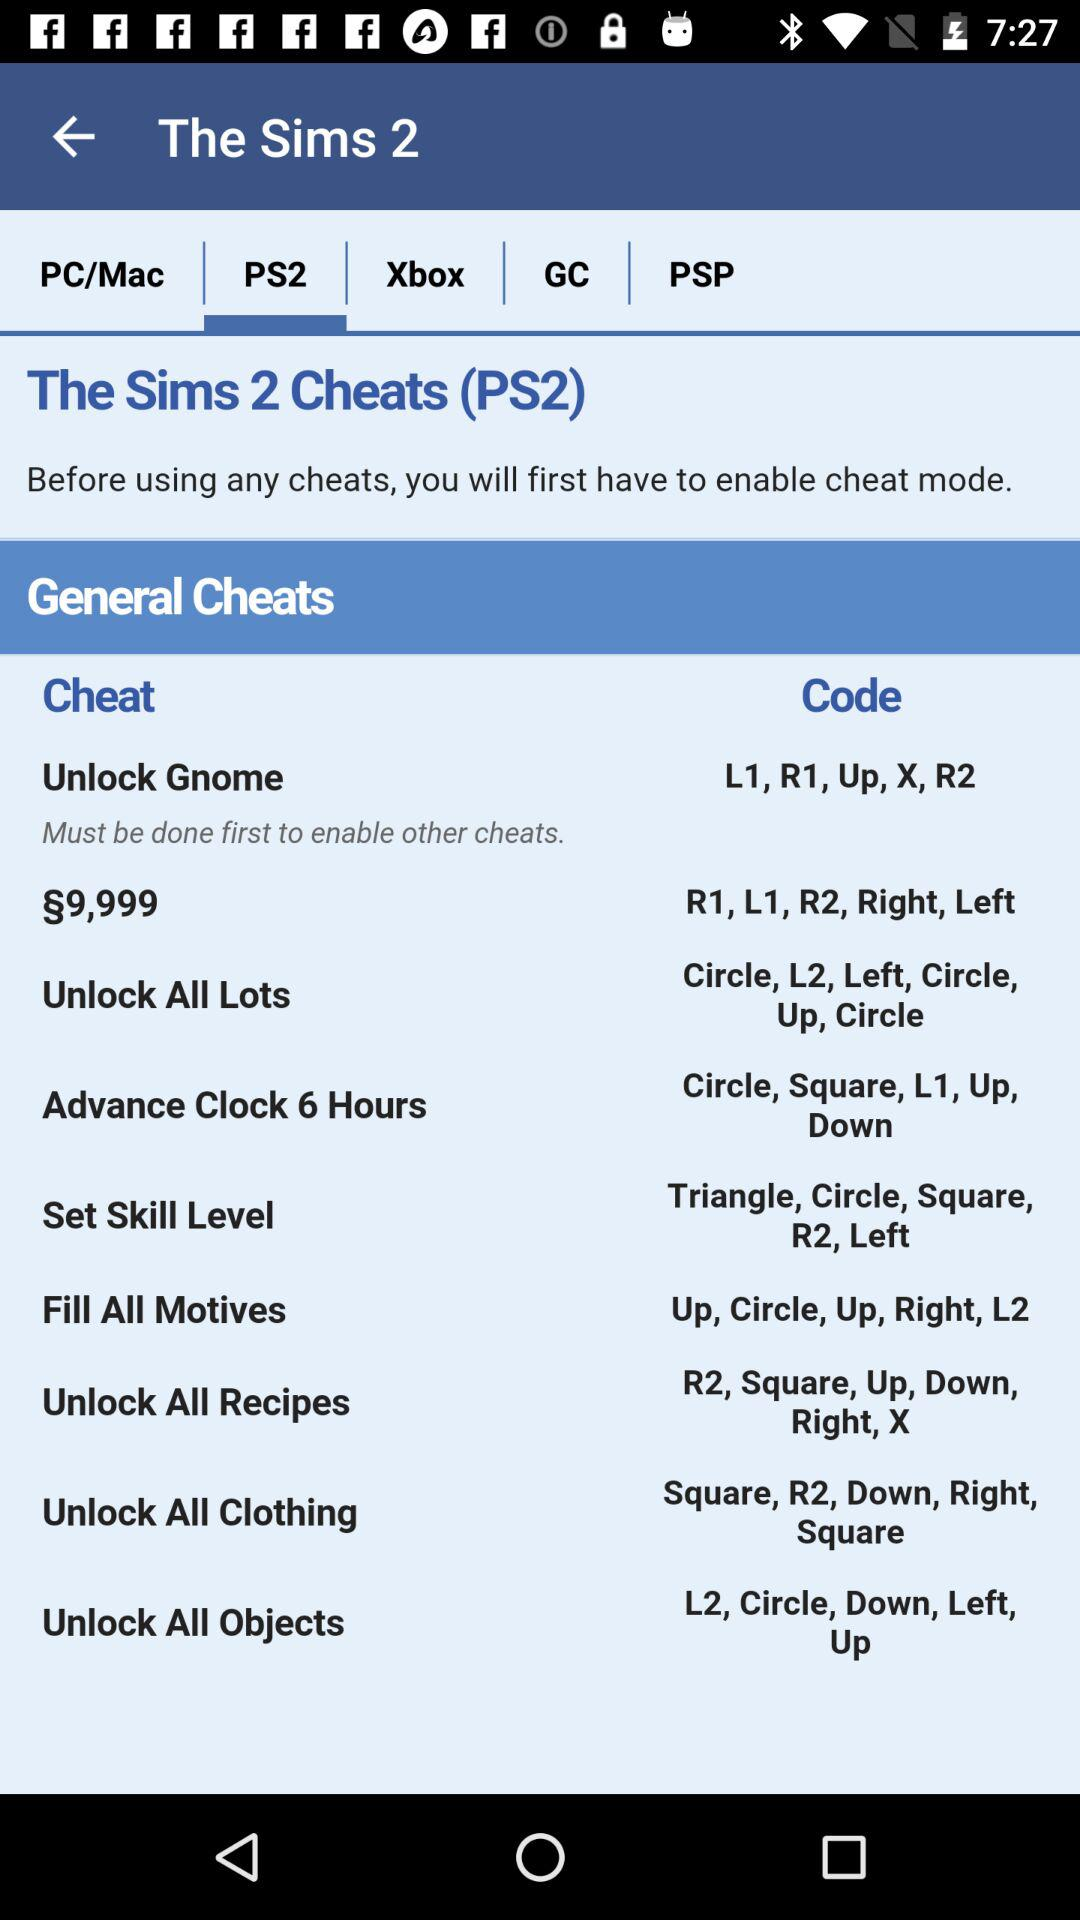What mode should be enabled before using any cheats? The mode that should be enabled is "cheat". 